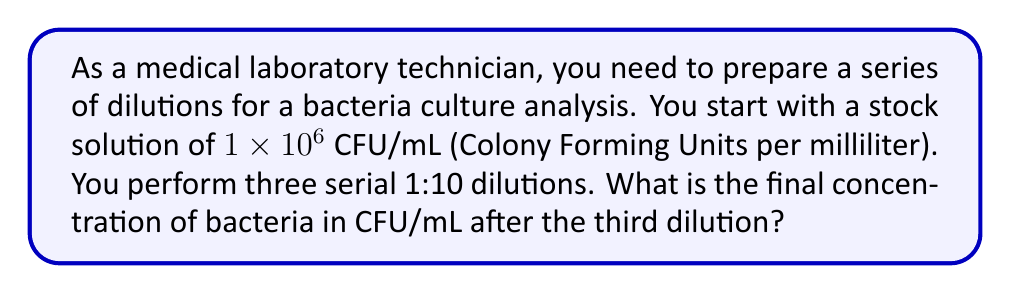Show me your answer to this math problem. To solve this problem, we need to understand the concept of serial dilutions and how they affect concentration. Let's break it down step-by-step:

1) Initial concentration: $C_0 = 1 \times 10^6$ CFU/mL

2) For each 1:10 dilution, we multiply the concentration by $\frac{1}{10}$ or $0.1$:

   First dilution: $C_1 = C_0 \times 0.1 = (1 \times 10^6) \times 0.1 = 1 \times 10^5$ CFU/mL

   Second dilution: $C_2 = C_1 \times 0.1 = (1 \times 10^5) \times 0.1 = 1 \times 10^4$ CFU/mL

   Third dilution: $C_3 = C_2 \times 0.1 = (1 \times 10^4) \times 0.1 = 1 \times 10^3$ CFU/mL

3) Alternatively, we can calculate this in one step:

   $$C_3 = C_0 \times (0.1)^3 = (1 \times 10^6) \times (0.001) = 1 \times 10^3 \text{ CFU/mL}$$

   This is because $(0.1)^3 = 0.001$, which is equivalent to dividing by 1000.

Therefore, after three 1:10 dilutions, the final concentration is $1 \times 10^3$ CFU/mL.
Answer: $1 \times 10^3$ CFU/mL 